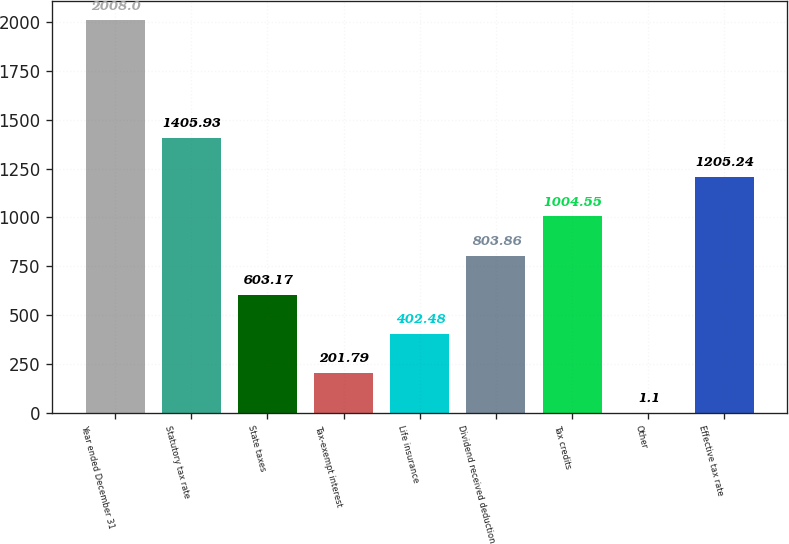<chart> <loc_0><loc_0><loc_500><loc_500><bar_chart><fcel>Year ended December 31<fcel>Statutory tax rate<fcel>State taxes<fcel>Tax-exempt interest<fcel>Life insurance<fcel>Dividend received deduction<fcel>Tax credits<fcel>Other<fcel>Effective tax rate<nl><fcel>2008<fcel>1405.93<fcel>603.17<fcel>201.79<fcel>402.48<fcel>803.86<fcel>1004.55<fcel>1.1<fcel>1205.24<nl></chart> 